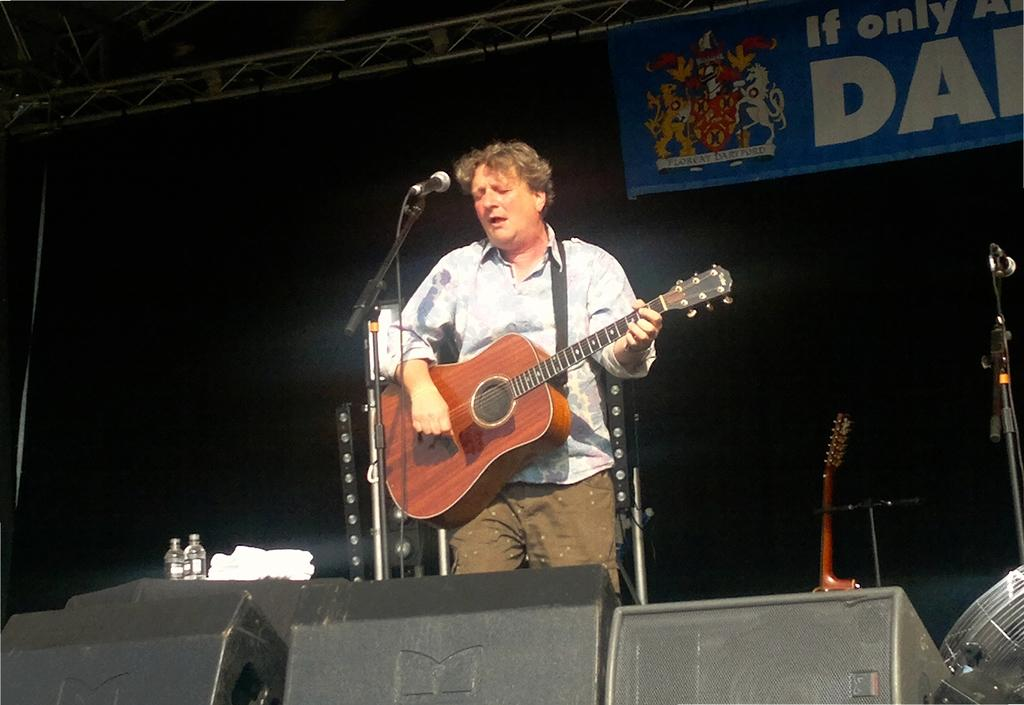What is the main subject of the image? There is a man in the image. What is the man doing in the image? The man is standing, playing the guitar, and singing into a microphone. What type of tree can be seen in the background of the image? There is no tree present in the image; it only features a man standing, playing the guitar, and singing into a microphone. 